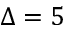<formula> <loc_0><loc_0><loc_500><loc_500>\Delta = 5</formula> 